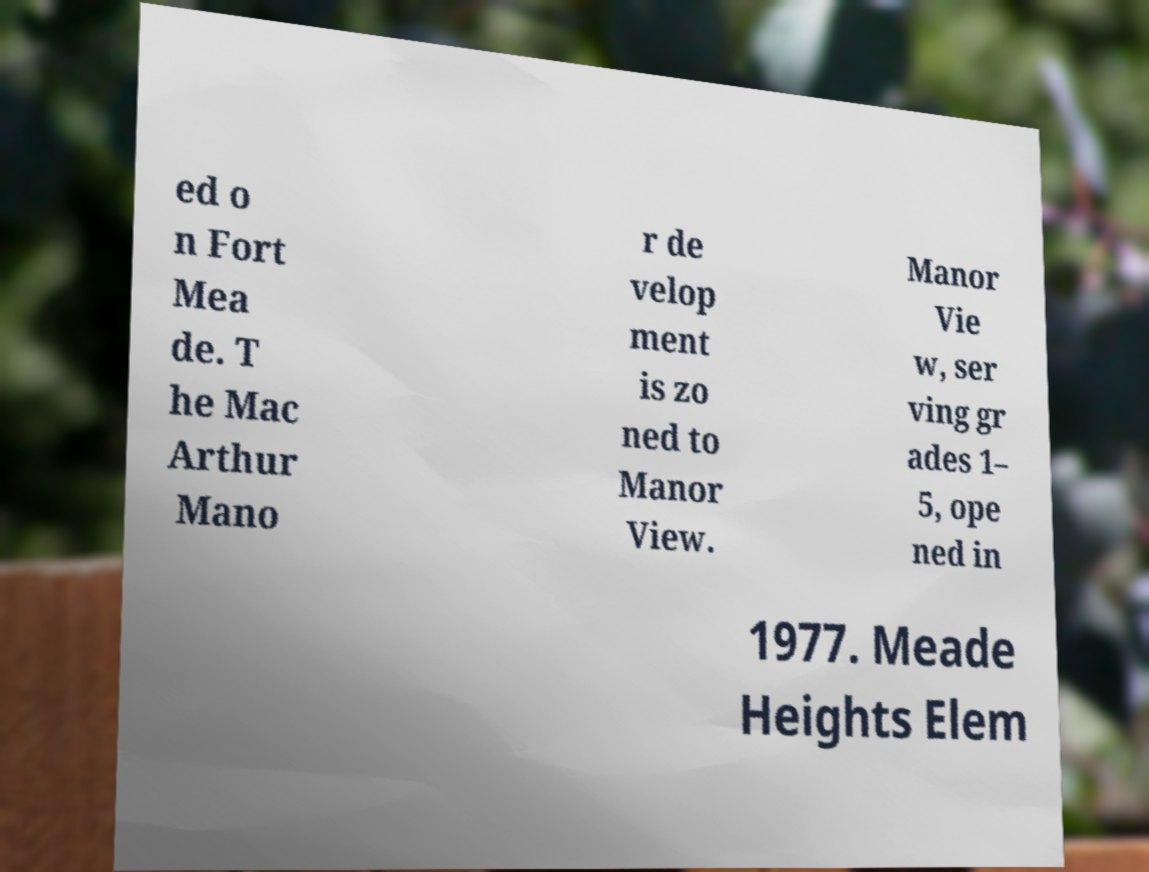Can you read and provide the text displayed in the image?This photo seems to have some interesting text. Can you extract and type it out for me? ed o n Fort Mea de. T he Mac Arthur Mano r de velop ment is zo ned to Manor View. Manor Vie w, ser ving gr ades 1– 5, ope ned in 1977. Meade Heights Elem 